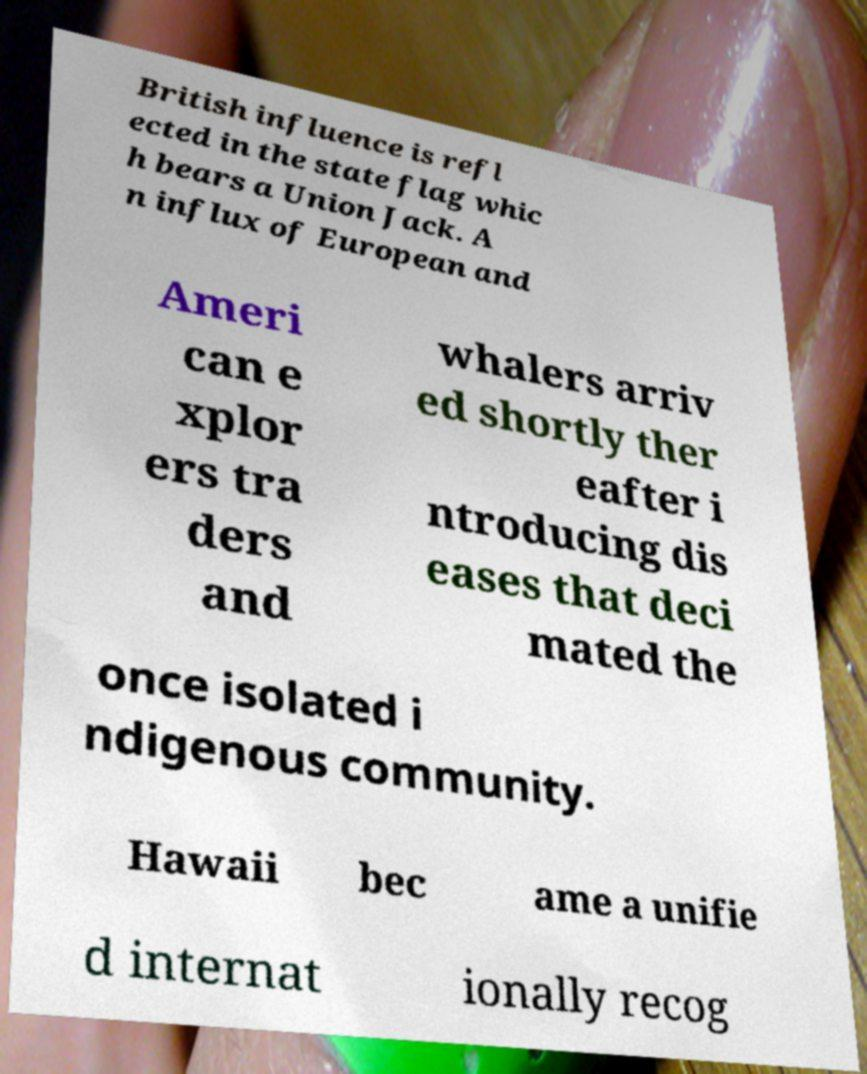Could you extract and type out the text from this image? British influence is refl ected in the state flag whic h bears a Union Jack. A n influx of European and Ameri can e xplor ers tra ders and whalers arriv ed shortly ther eafter i ntroducing dis eases that deci mated the once isolated i ndigenous community. Hawaii bec ame a unifie d internat ionally recog 